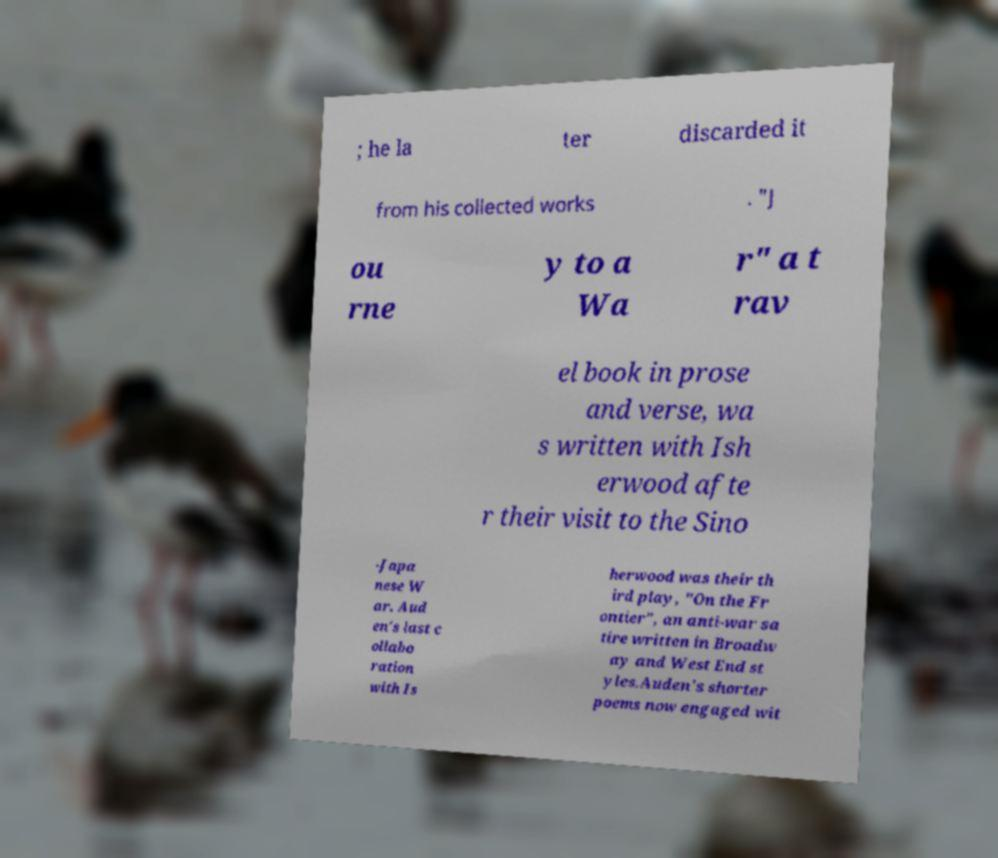Please identify and transcribe the text found in this image. ; he la ter discarded it from his collected works . "J ou rne y to a Wa r" a t rav el book in prose and verse, wa s written with Ish erwood afte r their visit to the Sino -Japa nese W ar. Aud en's last c ollabo ration with Is herwood was their th ird play, "On the Fr ontier", an anti-war sa tire written in Broadw ay and West End st yles.Auden's shorter poems now engaged wit 